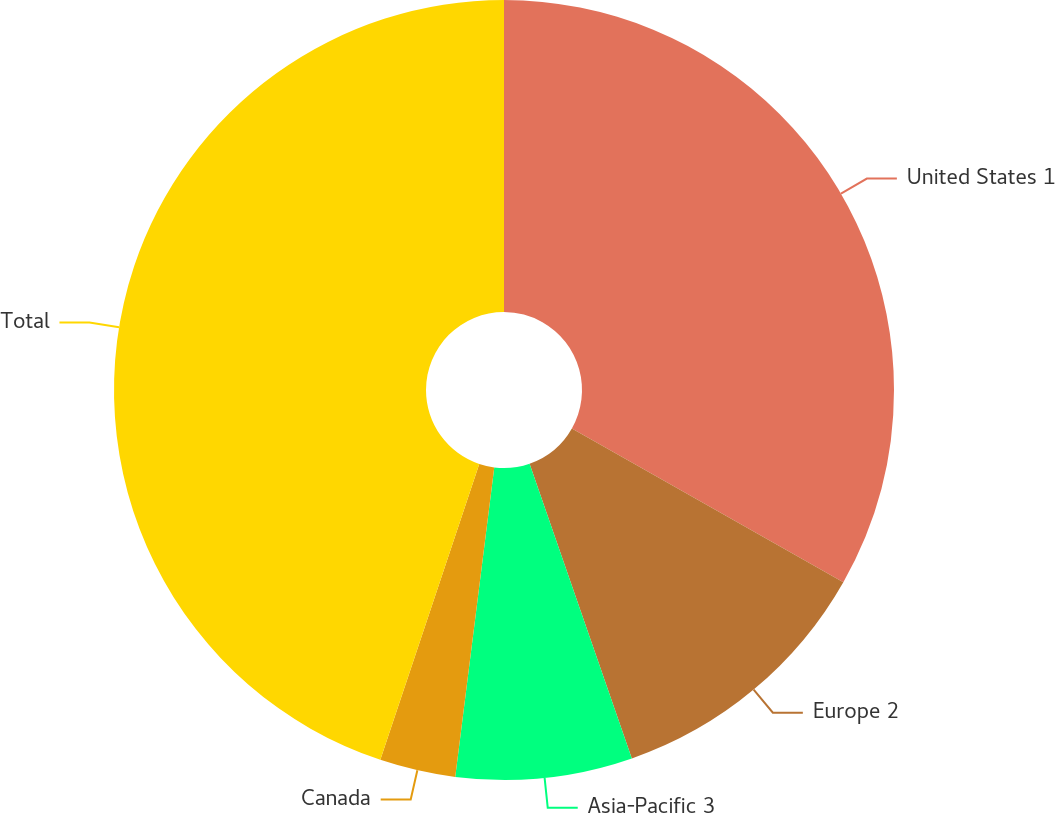<chart> <loc_0><loc_0><loc_500><loc_500><pie_chart><fcel>United States 1<fcel>Europe 2<fcel>Asia-Pacific 3<fcel>Canada<fcel>Total<nl><fcel>33.2%<fcel>11.48%<fcel>7.31%<fcel>3.14%<fcel>44.86%<nl></chart> 